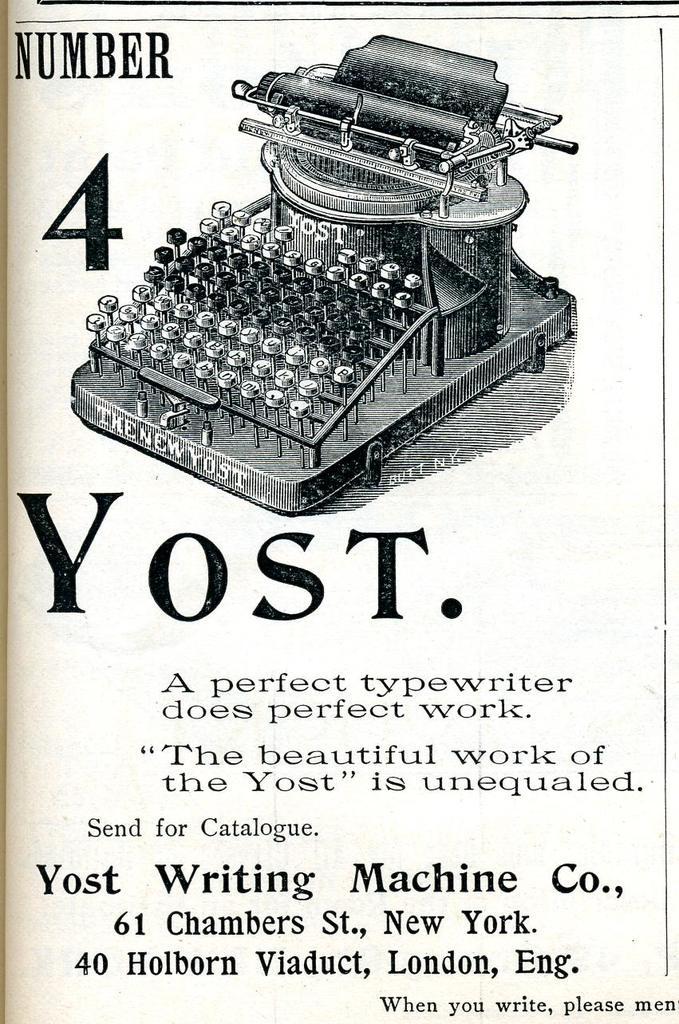What company made the type writer?
Your response must be concise. Yost. 